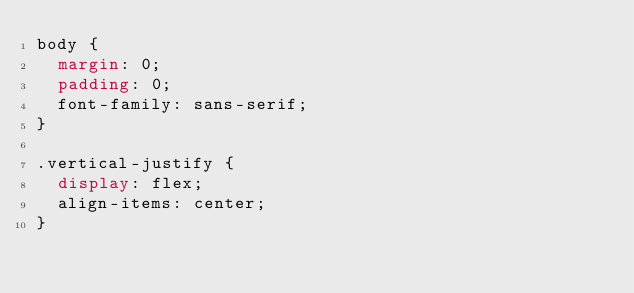<code> <loc_0><loc_0><loc_500><loc_500><_CSS_>body {
  margin: 0;
  padding: 0;
  font-family: sans-serif;
}

.vertical-justify {
  display: flex;
  align-items: center;
}
</code> 